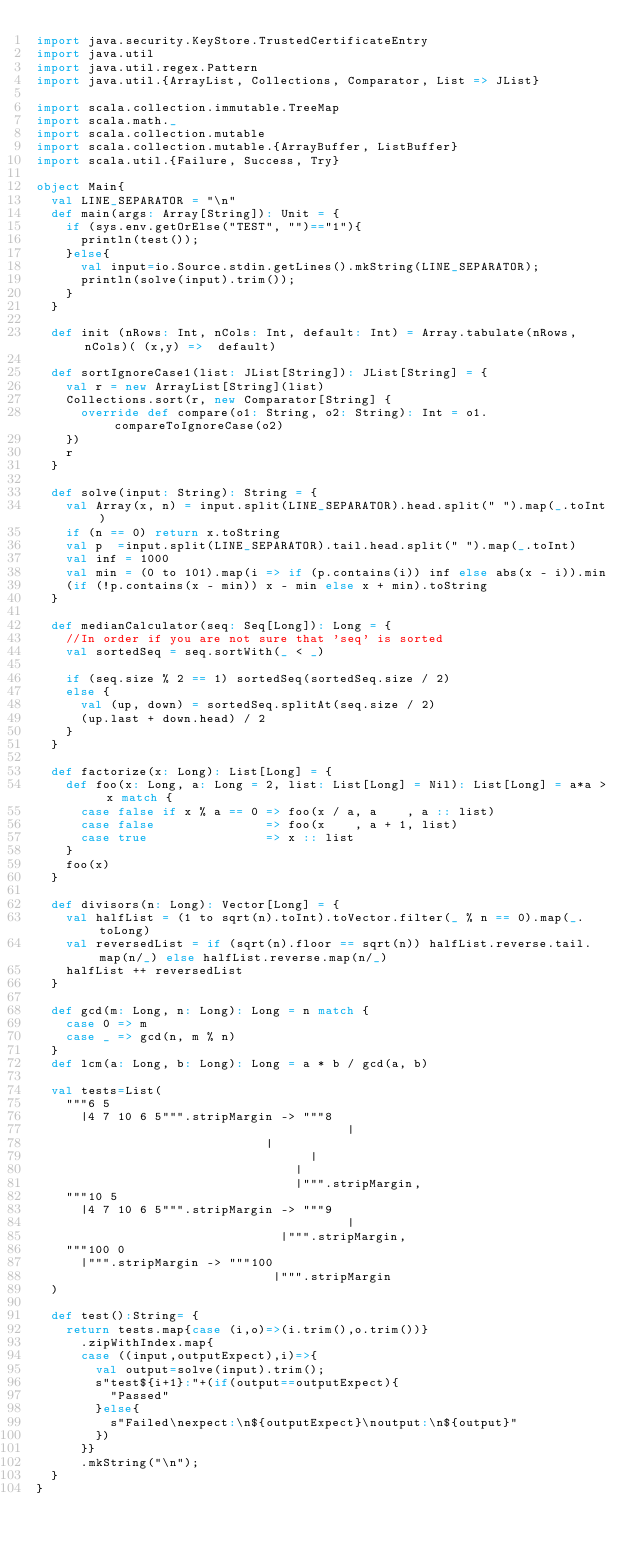Convert code to text. <code><loc_0><loc_0><loc_500><loc_500><_Scala_>import java.security.KeyStore.TrustedCertificateEntry
import java.util
import java.util.regex.Pattern
import java.util.{ArrayList, Collections, Comparator, List => JList}

import scala.collection.immutable.TreeMap
import scala.math._
import scala.collection.mutable
import scala.collection.mutable.{ArrayBuffer, ListBuffer}
import scala.util.{Failure, Success, Try}

object Main{
  val LINE_SEPARATOR = "\n"
  def main(args: Array[String]): Unit = {
    if (sys.env.getOrElse("TEST", "")=="1"){
      println(test());
    }else{
      val input=io.Source.stdin.getLines().mkString(LINE_SEPARATOR);
      println(solve(input).trim());
    }
  }

  def init (nRows: Int, nCols: Int, default: Int) = Array.tabulate(nRows,nCols)( (x,y) =>  default)

  def sortIgnoreCase1(list: JList[String]): JList[String] = {
    val r = new ArrayList[String](list)
    Collections.sort(r, new Comparator[String] {
      override def compare(o1: String, o2: String): Int = o1.compareToIgnoreCase(o2)
    })
    r
  }

  def solve(input: String): String = {
    val Array(x, n) = input.split(LINE_SEPARATOR).head.split(" ").map(_.toInt)
    if (n == 0) return x.toString
    val p  =input.split(LINE_SEPARATOR).tail.head.split(" ").map(_.toInt)
    val inf = 1000
    val min = (0 to 101).map(i => if (p.contains(i)) inf else abs(x - i)).min
    (if (!p.contains(x - min)) x - min else x + min).toString
  }

  def medianCalculator(seq: Seq[Long]): Long = {
    //In order if you are not sure that 'seq' is sorted
    val sortedSeq = seq.sortWith(_ < _)

    if (seq.size % 2 == 1) sortedSeq(sortedSeq.size / 2)
    else {
      val (up, down) = sortedSeq.splitAt(seq.size / 2)
      (up.last + down.head) / 2
    }
  }

  def factorize(x: Long): List[Long] = {
    def foo(x: Long, a: Long = 2, list: List[Long] = Nil): List[Long] = a*a > x match {
      case false if x % a == 0 => foo(x / a, a    , a :: list)
      case false               => foo(x    , a + 1, list)
      case true                => x :: list
    }
    foo(x)
  }

  def divisors(n: Long): Vector[Long] = {
    val halfList = (1 to sqrt(n).toInt).toVector.filter(_ % n == 0).map(_.toLong)
    val reversedList = if (sqrt(n).floor == sqrt(n)) halfList.reverse.tail.map(n/_) else halfList.reverse.map(n/_)
    halfList ++ reversedList
  }

  def gcd(m: Long, n: Long): Long = n match {
    case 0 => m
    case _ => gcd(n, m % n)
  }
  def lcm(a: Long, b: Long): Long = a * b / gcd(a, b)

  val tests=List(
    """6 5
      |4 7 10 6 5""".stripMargin -> """8
                                          |
                               |
                                     |
                                   |
                                   |""".stripMargin,
    """10 5
      |4 7 10 6 5""".stripMargin -> """9
                                          |
                                 |""".stripMargin,
    """100 0
      |""".stripMargin -> """100
                                |""".stripMargin
  )

  def test():String= {
    return tests.map{case (i,o)=>(i.trim(),o.trim())}
      .zipWithIndex.map{
      case ((input,outputExpect),i)=>{
        val output=solve(input).trim();
        s"test${i+1}:"+(if(output==outputExpect){
          "Passed"
        }else{
          s"Failed\nexpect:\n${outputExpect}\noutput:\n${output}"
        })
      }}
      .mkString("\n");
  }
}</code> 